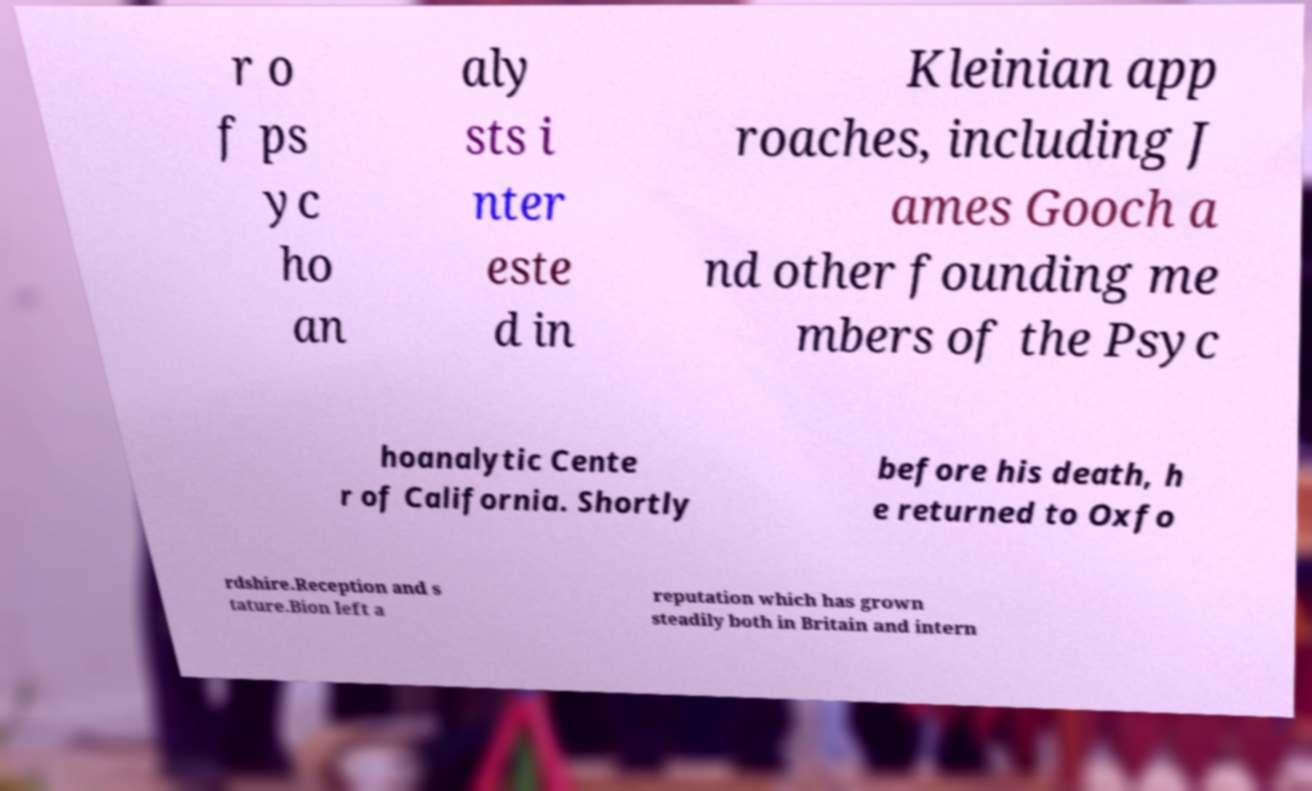For documentation purposes, I need the text within this image transcribed. Could you provide that? r o f ps yc ho an aly sts i nter este d in Kleinian app roaches, including J ames Gooch a nd other founding me mbers of the Psyc hoanalytic Cente r of California. Shortly before his death, h e returned to Oxfo rdshire.Reception and s tature.Bion left a reputation which has grown steadily both in Britain and intern 